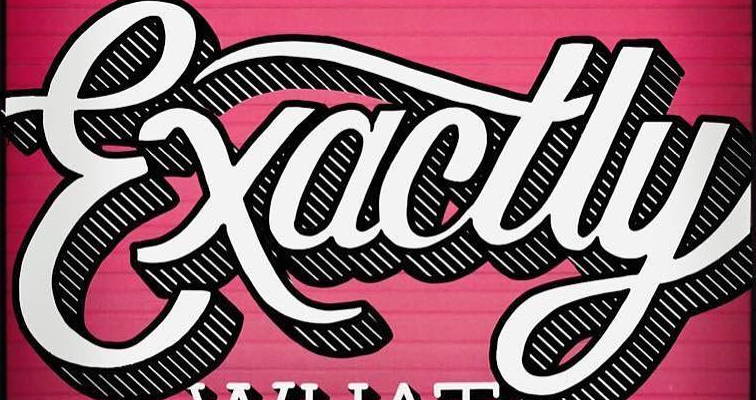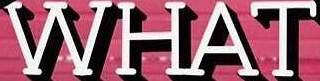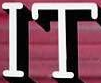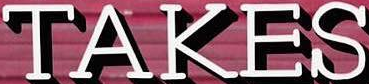Read the text from these images in sequence, separated by a semicolon. Exactly; WHAT; IT; TAKES 